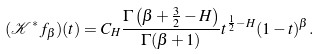<formula> <loc_0><loc_0><loc_500><loc_500>( \mathcal { K } ^ { * } f _ { \beta } ) ( t ) = C _ { H } \frac { \Gamma \left ( \beta + \frac { 3 } { 2 } - H \right ) } { \Gamma ( \beta + 1 ) } t ^ { \frac { 1 } { 2 } - H } ( 1 - t ) ^ { \beta } .</formula> 